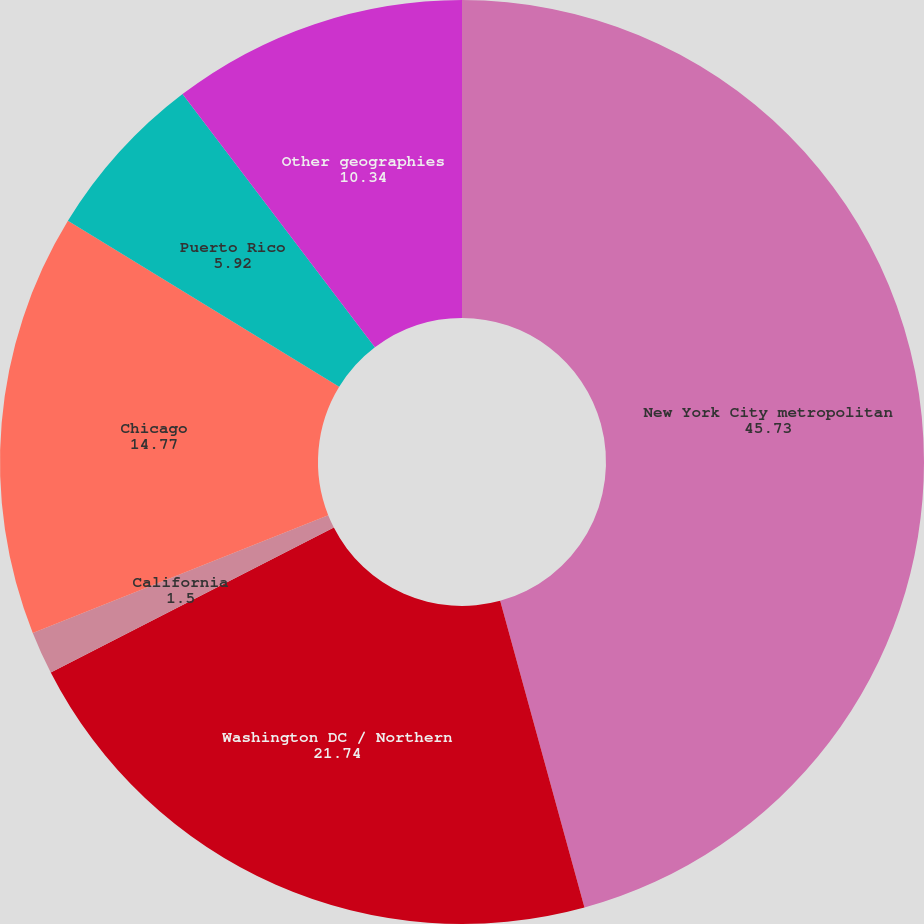Convert chart to OTSL. <chart><loc_0><loc_0><loc_500><loc_500><pie_chart><fcel>New York City metropolitan<fcel>Washington DC / Northern<fcel>California<fcel>Chicago<fcel>Puerto Rico<fcel>Other geographies<nl><fcel>45.73%<fcel>21.74%<fcel>1.5%<fcel>14.77%<fcel>5.92%<fcel>10.34%<nl></chart> 